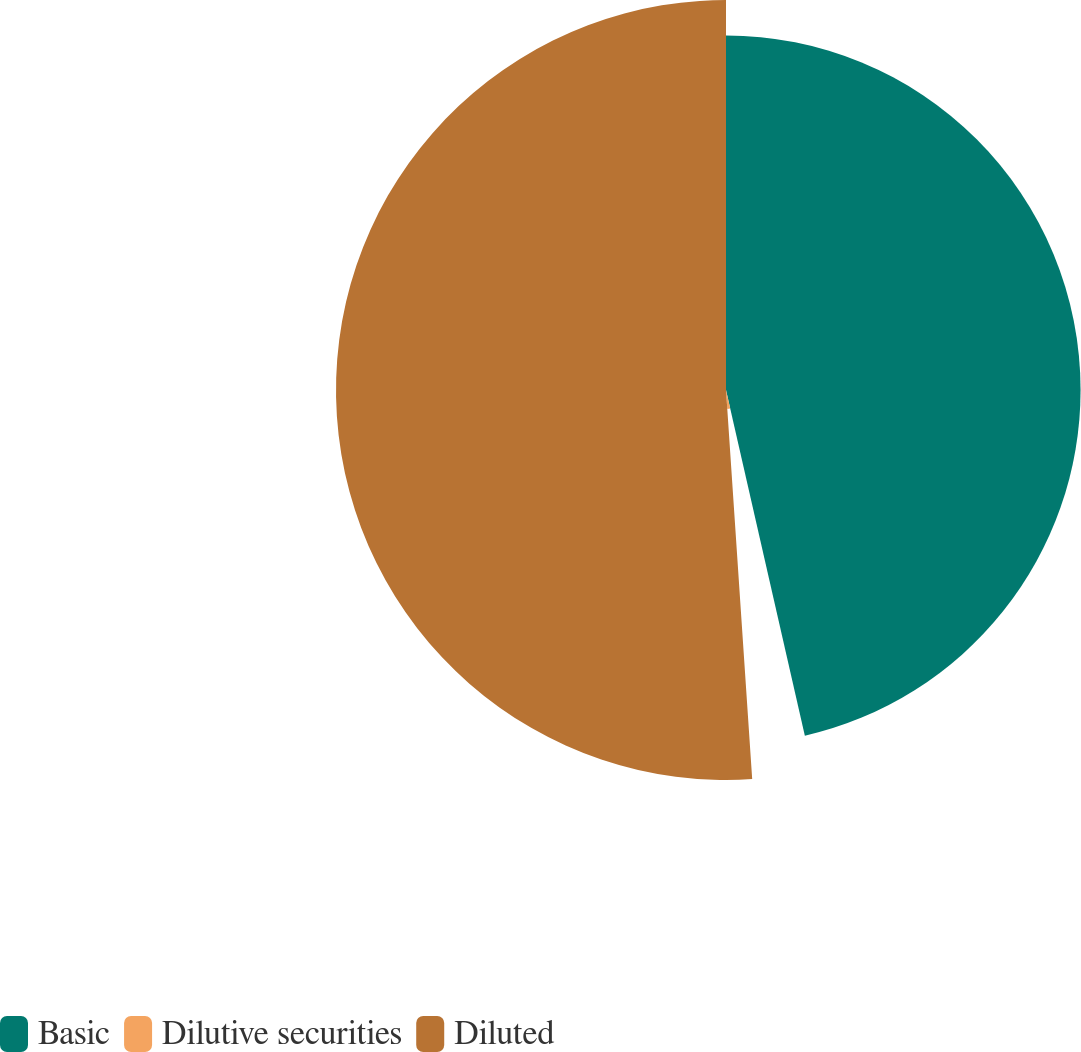<chart> <loc_0><loc_0><loc_500><loc_500><pie_chart><fcel>Basic<fcel>Dilutive securities<fcel>Diluted<nl><fcel>46.43%<fcel>2.5%<fcel>51.07%<nl></chart> 